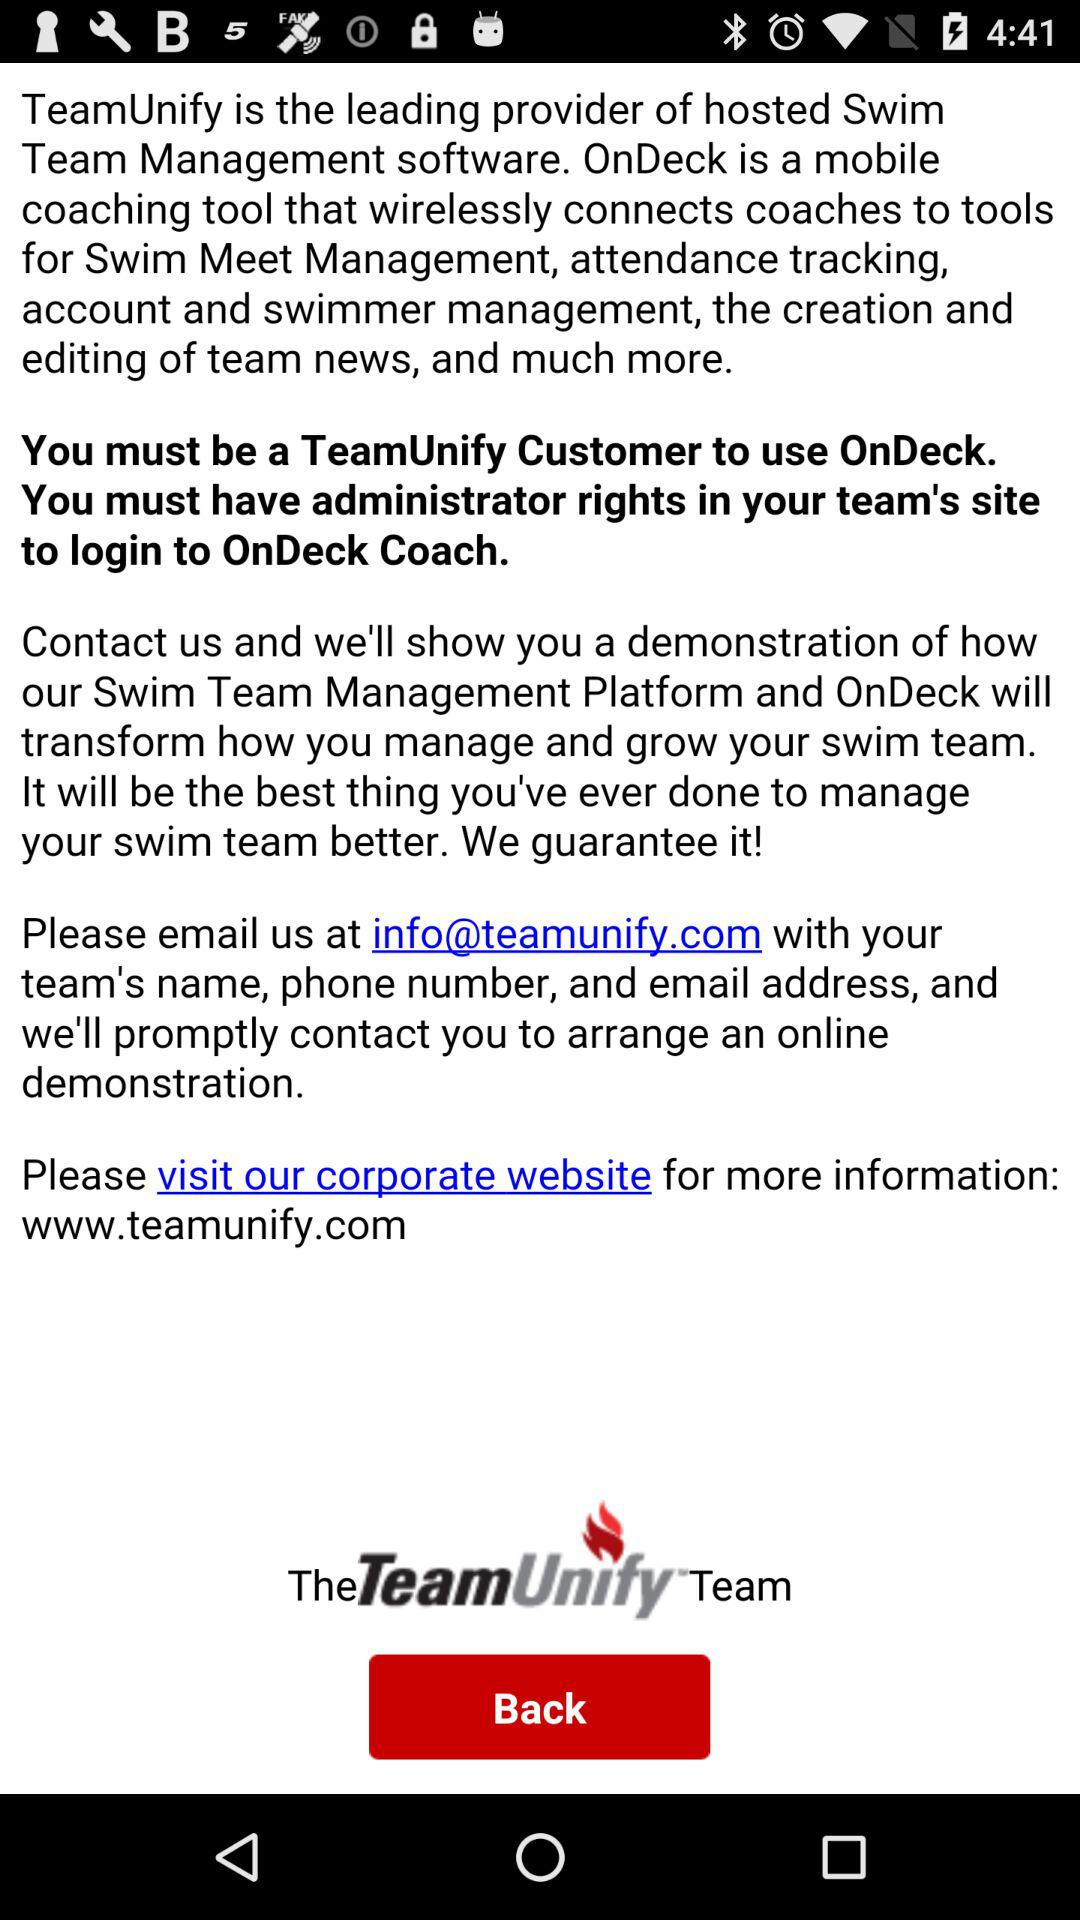What is the email address? The email address is info@teamunify.com. 